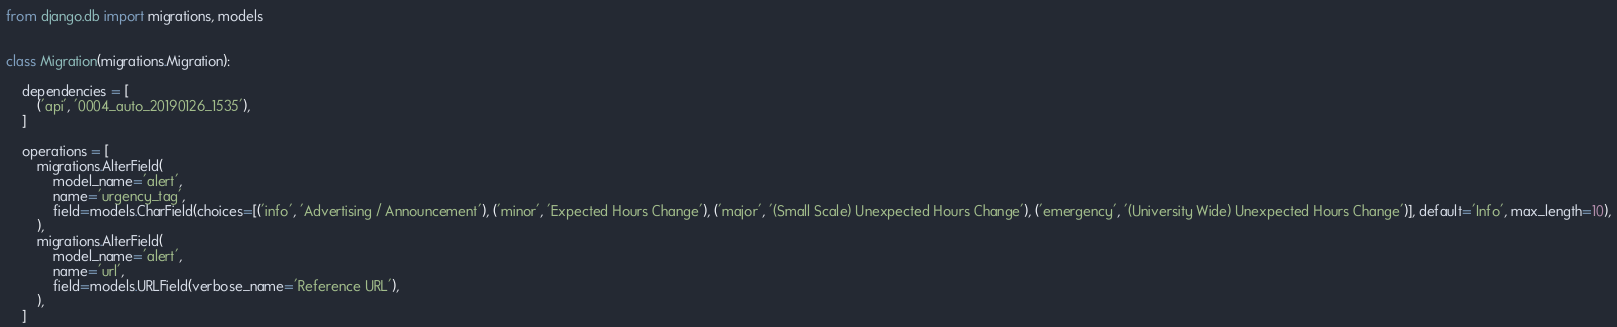Convert code to text. <code><loc_0><loc_0><loc_500><loc_500><_Python_>
from django.db import migrations, models


class Migration(migrations.Migration):

    dependencies = [
        ('api', '0004_auto_20190126_1535'),
    ]

    operations = [
        migrations.AlterField(
            model_name='alert',
            name='urgency_tag',
            field=models.CharField(choices=[('info', 'Advertising / Announcement'), ('minor', 'Expected Hours Change'), ('major', '(Small Scale) Unexpected Hours Change'), ('emergency', '(University Wide) Unexpected Hours Change')], default='Info', max_length=10),
        ),
        migrations.AlterField(
            model_name='alert',
            name='url',
            field=models.URLField(verbose_name='Reference URL'),
        ),
    ]
</code> 